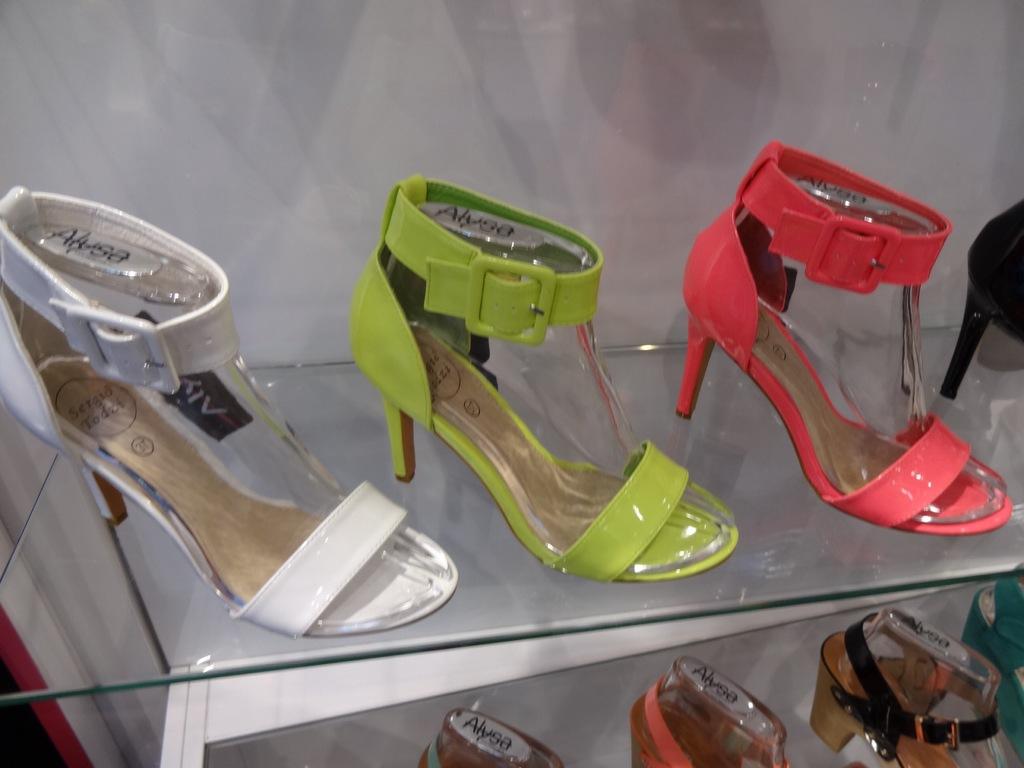What brand of shoes are these?
Your answer should be compact. Alysa. 